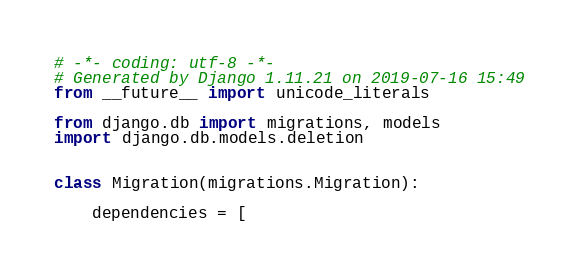<code> <loc_0><loc_0><loc_500><loc_500><_Python_># -*- coding: utf-8 -*-
# Generated by Django 1.11.21 on 2019-07-16 15:49
from __future__ import unicode_literals

from django.db import migrations, models
import django.db.models.deletion


class Migration(migrations.Migration):

    dependencies = [</code> 